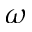Convert formula to latex. <formula><loc_0><loc_0><loc_500><loc_500>\omega</formula> 